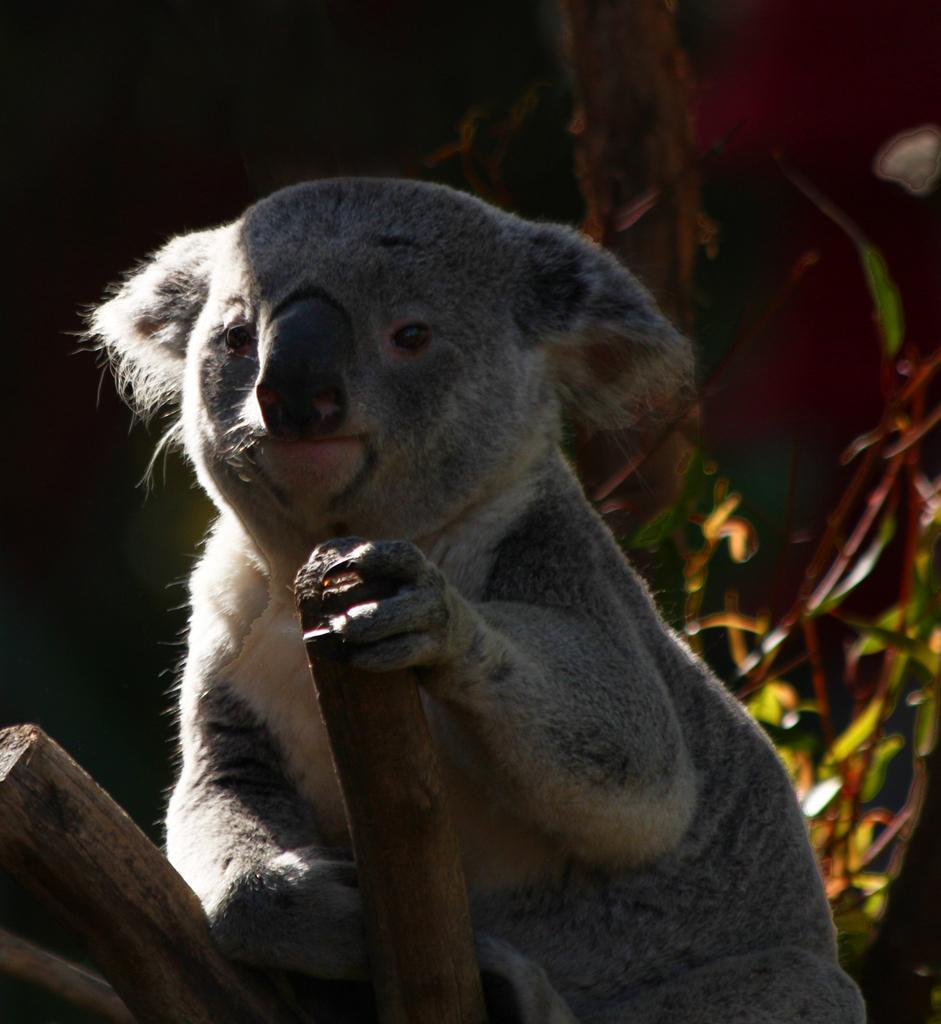Describe this image in one or two sentences. In this picture we can see koala. He is holding a wood. On the back we can see plant and wall. 